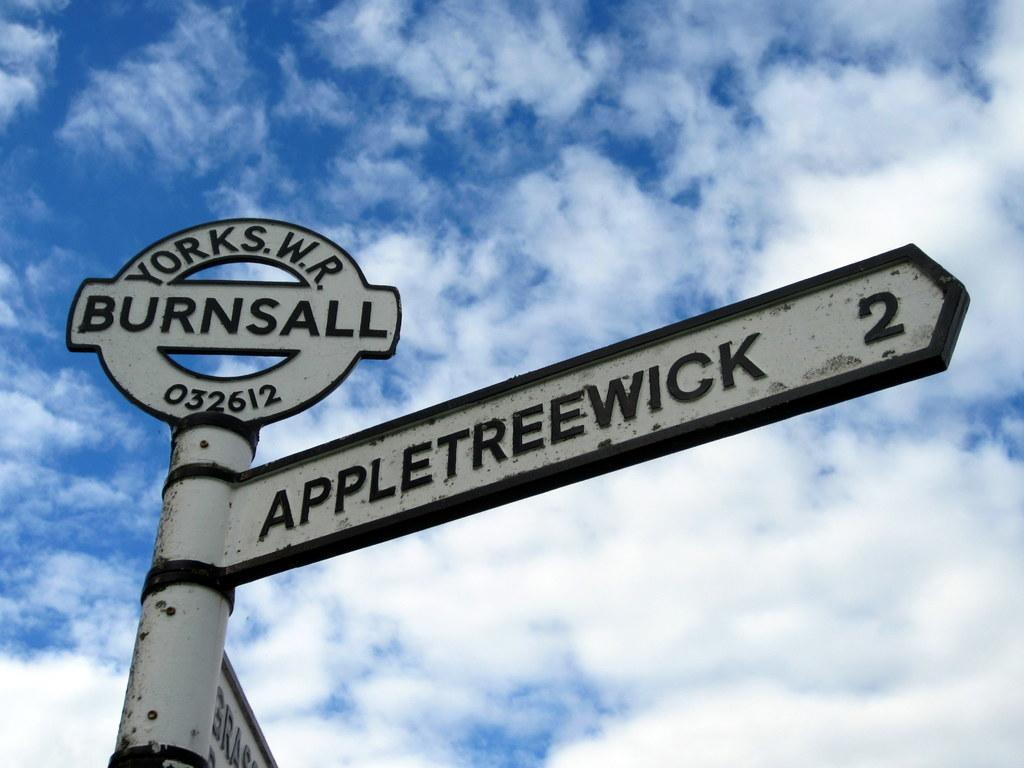<image>
Present a compact description of the photo's key features. A white and black sign points the way to appletreewick. 